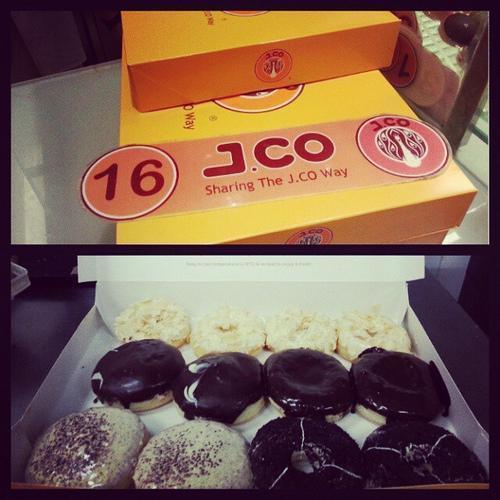How many donuts are shown?
Give a very brief answer. 12. How many donuts have chocolate icing?
Give a very brief answer. 4. How many donuts have visible holes in the middle?
Give a very brief answer. 6. 